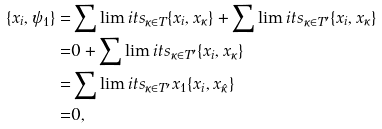Convert formula to latex. <formula><loc_0><loc_0><loc_500><loc_500>\{ x _ { i } , \psi _ { 1 } \} = & \sum \lim i t s _ { \kappa \in T } \{ x _ { i } , x _ { \kappa } \} + \sum \lim i t s _ { \kappa \in T ^ { \prime } } \{ x _ { i } , x _ { \kappa } \} \\ = & 0 + \sum \lim i t s _ { \kappa \in T ^ { \prime } } \{ x _ { i } , x _ { \kappa } \} \\ = & \sum \lim i t s _ { \kappa \in T ^ { \prime } } x _ { 1 } \{ x _ { i } , x _ { \hat { \kappa } } \} \\ = & 0 ,</formula> 